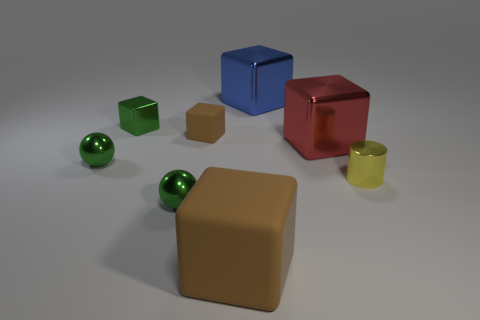Are there more tiny yellow things behind the green block than green metallic blocks?
Your answer should be compact. No. What number of objects are either tiny cubes or large things behind the red shiny cube?
Your answer should be very brief. 3. Are there more tiny brown things that are in front of the large brown cube than tiny cylinders that are behind the red thing?
Offer a terse response. No. There is a brown block that is behind the brown rubber thing that is in front of the brown thing that is behind the tiny yellow cylinder; what is its material?
Provide a succinct answer. Rubber. The big red thing that is made of the same material as the cylinder is what shape?
Keep it short and to the point. Cube. There is a tiny thing that is in front of the tiny yellow shiny cylinder; is there a green metallic thing on the left side of it?
Ensure brevity in your answer.  Yes. How big is the blue shiny thing?
Offer a terse response. Large. How many objects are big rubber objects or tiny red rubber cubes?
Give a very brief answer. 1. Are the large block that is right of the blue block and the big block in front of the red shiny object made of the same material?
Your answer should be very brief. No. What is the color of the large object that is the same material as the large blue cube?
Ensure brevity in your answer.  Red. 